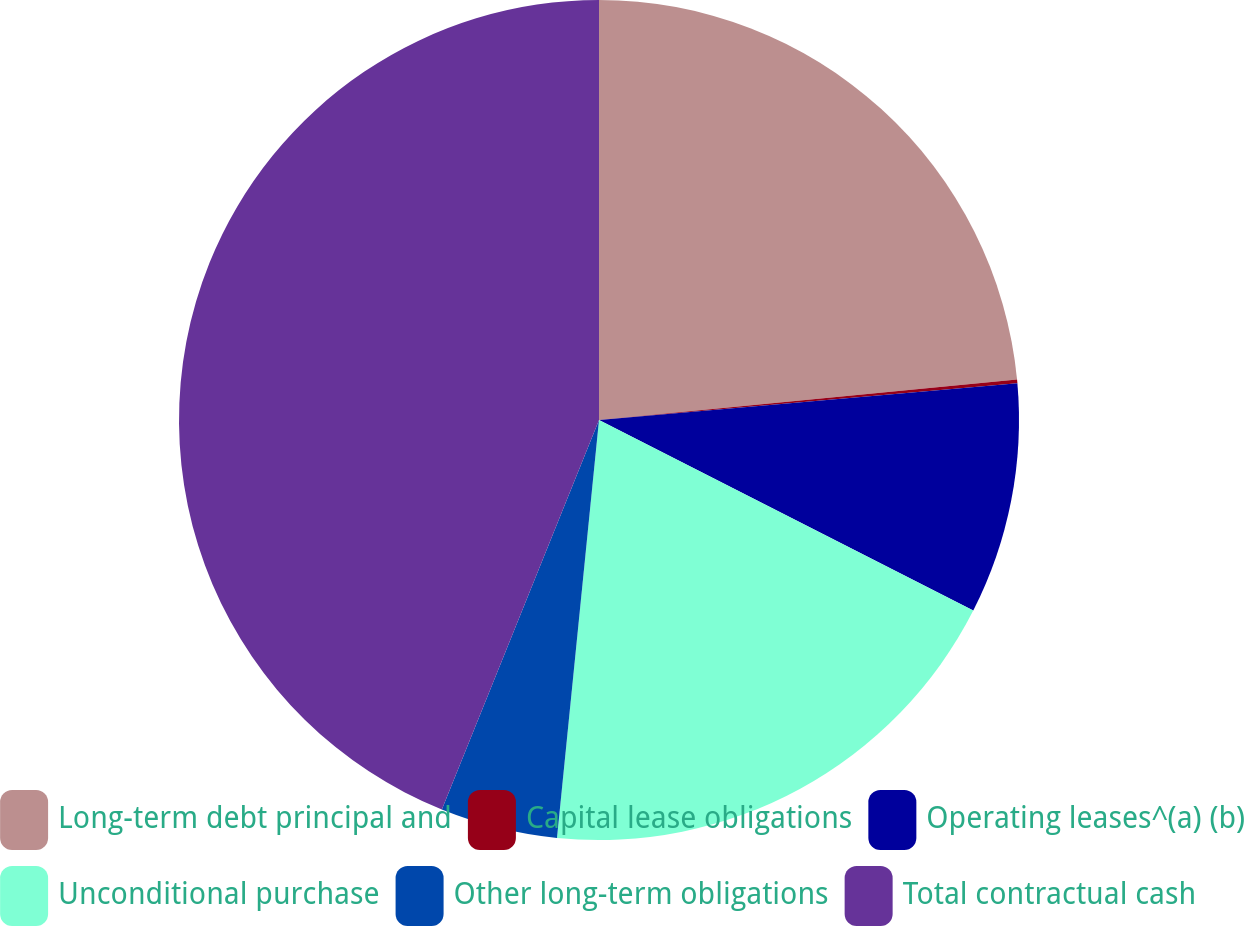Convert chart to OTSL. <chart><loc_0><loc_0><loc_500><loc_500><pie_chart><fcel>Long-term debt principal and<fcel>Capital lease obligations<fcel>Operating leases^(a) (b)<fcel>Unconditional purchase<fcel>Other long-term obligations<fcel>Total contractual cash<nl><fcel>23.47%<fcel>0.14%<fcel>8.89%<fcel>19.1%<fcel>4.51%<fcel>43.9%<nl></chart> 